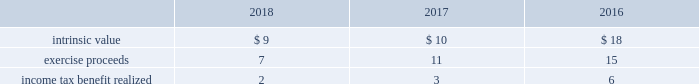The table provides the weighted average assumptions used in the black-scholes option-pricing model for grants and the resulting weighted average grant date fair value per share of stock options granted for the years ended december 31: .
Stock units during 2018 , 2017 and 2016 , the company granted rsus to certain employees under the 2007 plan and 2017 omnibus plan , as applicable .
Rsus generally vest based on continued employment with the company over periods ranging from one to three years. .
What was the lowest intrinsic value per share for the calculation in the table? 
Computations: table_min(intrinsic value, none)
Answer: 9.0. The table provides the weighted average assumptions used in the black-scholes option-pricing model for grants and the resulting weighted average grant date fair value per share of stock options granted for the years ended december 31: .
Stock units during 2018 , 2017 and 2016 , the company granted rsus to certain employees under the 2007 plan and 2017 omnibus plan , as applicable .
Rsus generally vest based on continued employment with the company over periods ranging from one to three years. .
At what tax rate was exercise proceeds taxed at in 2018? 
Computations: (2 * 7)
Answer: 14.0. 